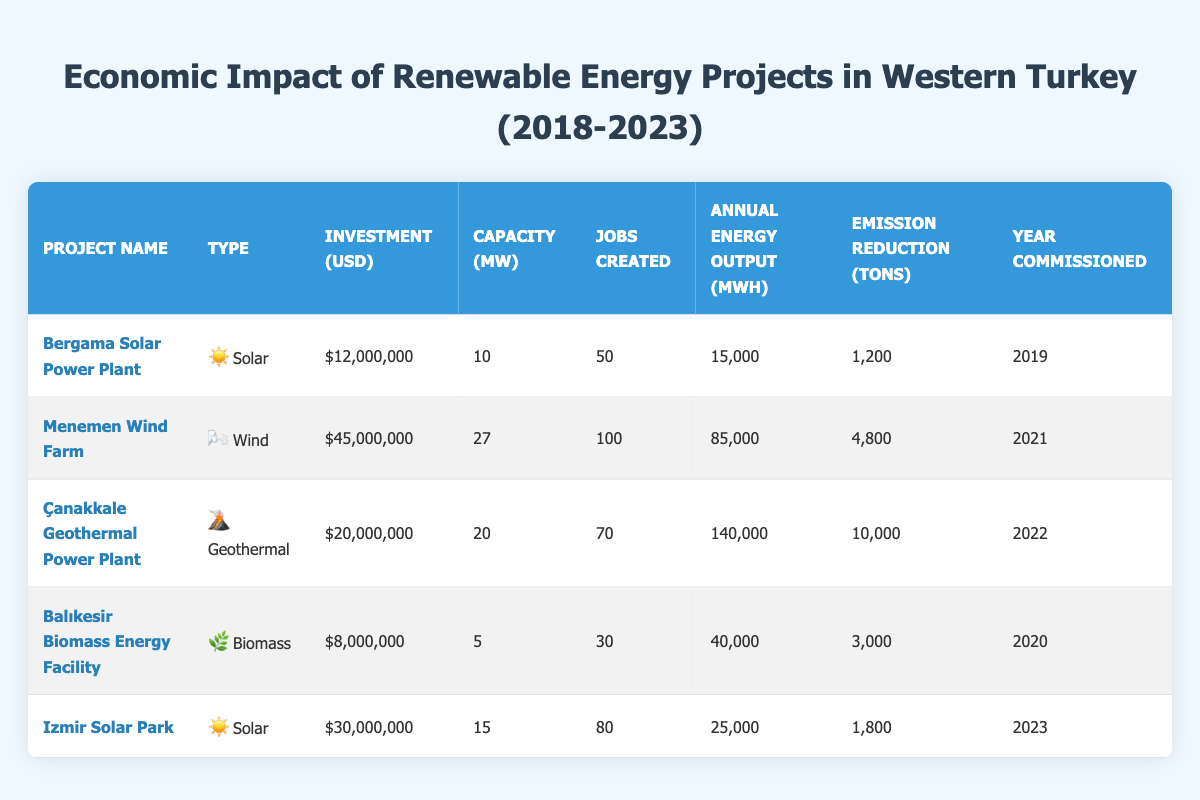What is the total investment amount for all renewable energy projects? By reviewing the investment amounts for each project: Bergama Solar Power Plant ($12,000,000), Menemen Wind Farm ($45,000,000), Çanakkale Geothermal Power Plant ($20,000,000), Balıkesir Biomass Energy Facility ($8,000,000), and Izmir Solar Park ($30,000,000). Adding them together gives $12,000,000 + $45,000,000 + $20,000,000 + $8,000,000 + $30,000,000 = $115,000,000.
Answer: 115000000 Which project has the highest emissions reduction in tons? Comparing the emission reductions of each project, we see that Menemen Wind Farm reduces 4,800 tons, Çanakkale Geothermal Power Plant reduces 10,000 tons, Balıkesir Biomass Energy Facility reduces 3,000 tons, Bergama Solar Power Plant reduces 1,200 tons, and Izmir Solar Park reduces 1,800 tons. The highest reduction is 10,000 tons from Çanakkale Geothermal Power Plant.
Answer: Çanakkale Geothermal Power Plant How many jobs were created in total by all projects? The total jobs created can be calculated by adding the jobs from each project: 50 (Bergama) + 100 (Menemen) + 70 (Çanakkale) + 30 (Balıkesir) + 80 (Izmir) = 430 jobs in total.
Answer: 430 Is it true that the total annual energy output from all projects exceeds 300,000 MWh? The annual energy outputs are: Bergama Solar Power Plant (15,000 MWh), Menemen Wind Farm (85,000 MWh), Çanakkale Geothermal Power Plant (140,000 MWh), Balıkesir Biomass Energy Facility (40,000 MWh), and Izmir Solar Park (25,000 MWh). Adding these gives 15,000 + 85,000 + 140,000 + 40,000 + 25,000 = 305,000 MWh, which exceeds 300,000 MWh, so the statement is true.
Answer: True What is the average capacity in MW across all renewable energy projects? To find the average capacity, sum the capacities: 10 (Bergama) + 27 (Menemen) + 20 (Çanakkale) + 5 (Balıkesir) + 15 (Izmir) = 77 MW. There are 5 projects, so the average is 77 MW / 5 = 15.4 MW.
Answer: 15.4 